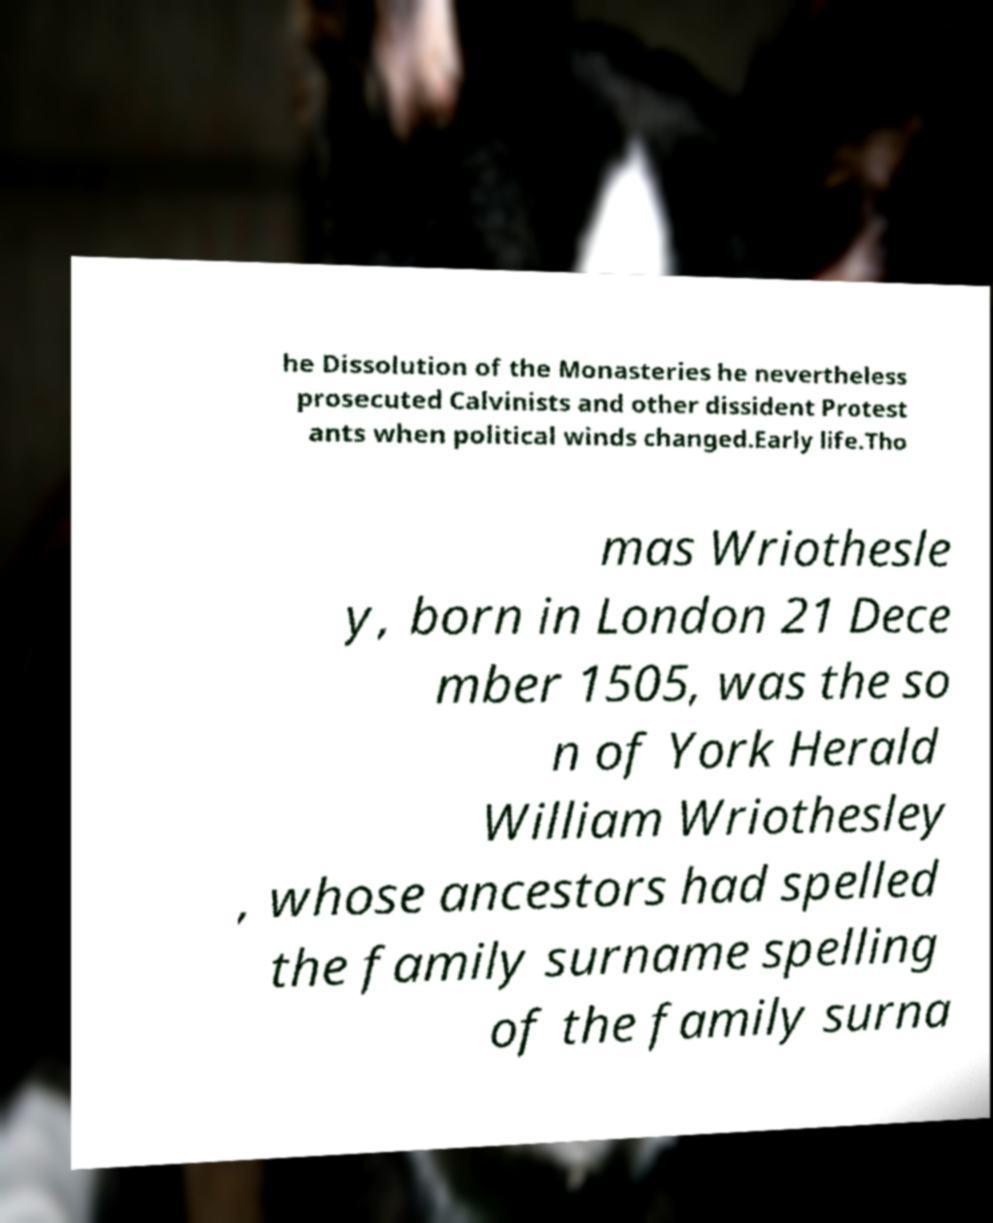Please read and relay the text visible in this image. What does it say? he Dissolution of the Monasteries he nevertheless prosecuted Calvinists and other dissident Protest ants when political winds changed.Early life.Tho mas Wriothesle y, born in London 21 Dece mber 1505, was the so n of York Herald William Wriothesley , whose ancestors had spelled the family surname spelling of the family surna 